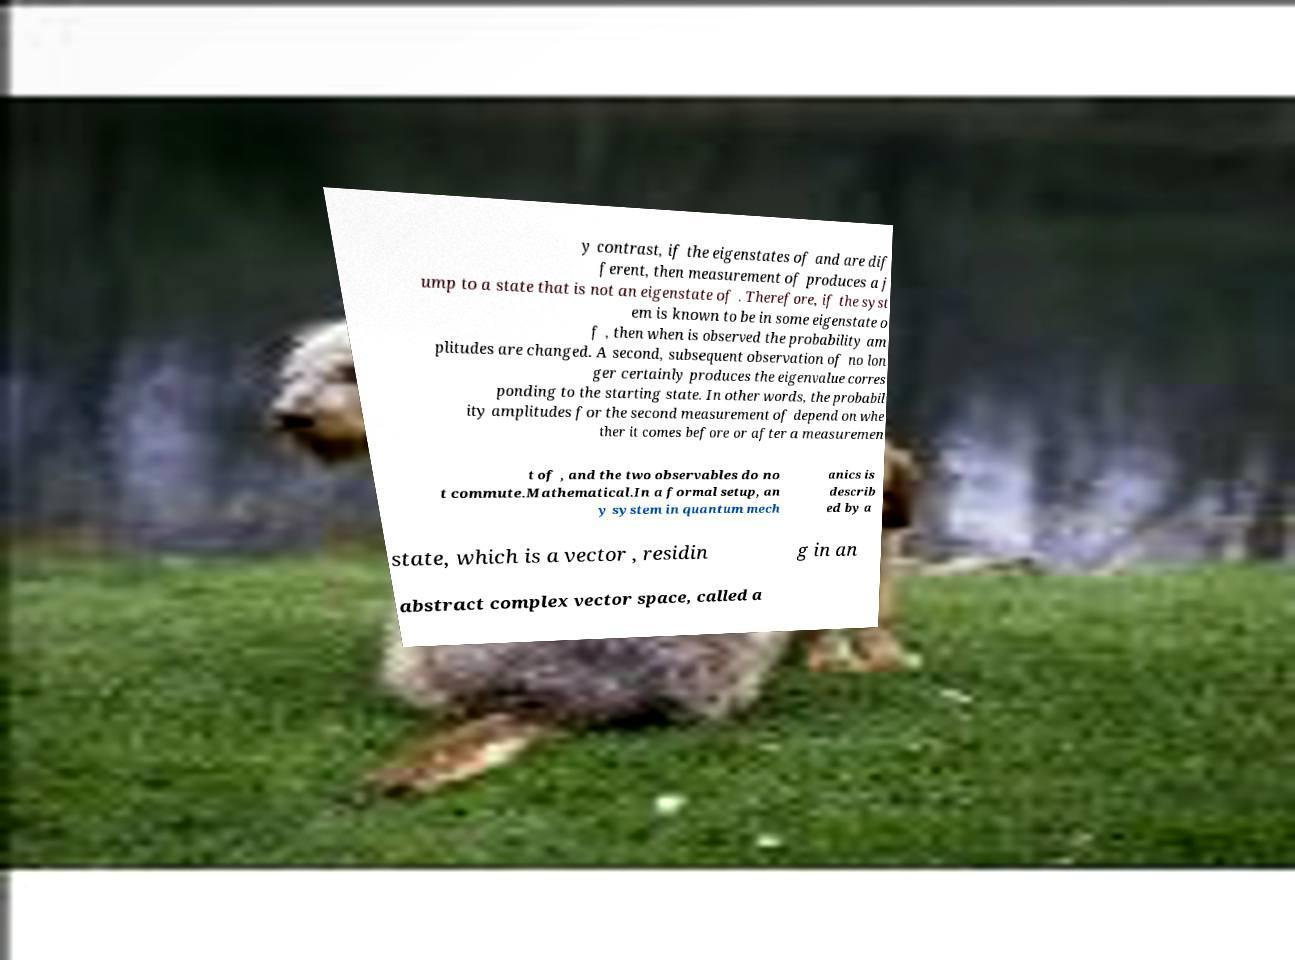Could you extract and type out the text from this image? y contrast, if the eigenstates of and are dif ferent, then measurement of produces a j ump to a state that is not an eigenstate of . Therefore, if the syst em is known to be in some eigenstate o f , then when is observed the probability am plitudes are changed. A second, subsequent observation of no lon ger certainly produces the eigenvalue corres ponding to the starting state. In other words, the probabil ity amplitudes for the second measurement of depend on whe ther it comes before or after a measuremen t of , and the two observables do no t commute.Mathematical.In a formal setup, an y system in quantum mech anics is describ ed by a state, which is a vector , residin g in an abstract complex vector space, called a 